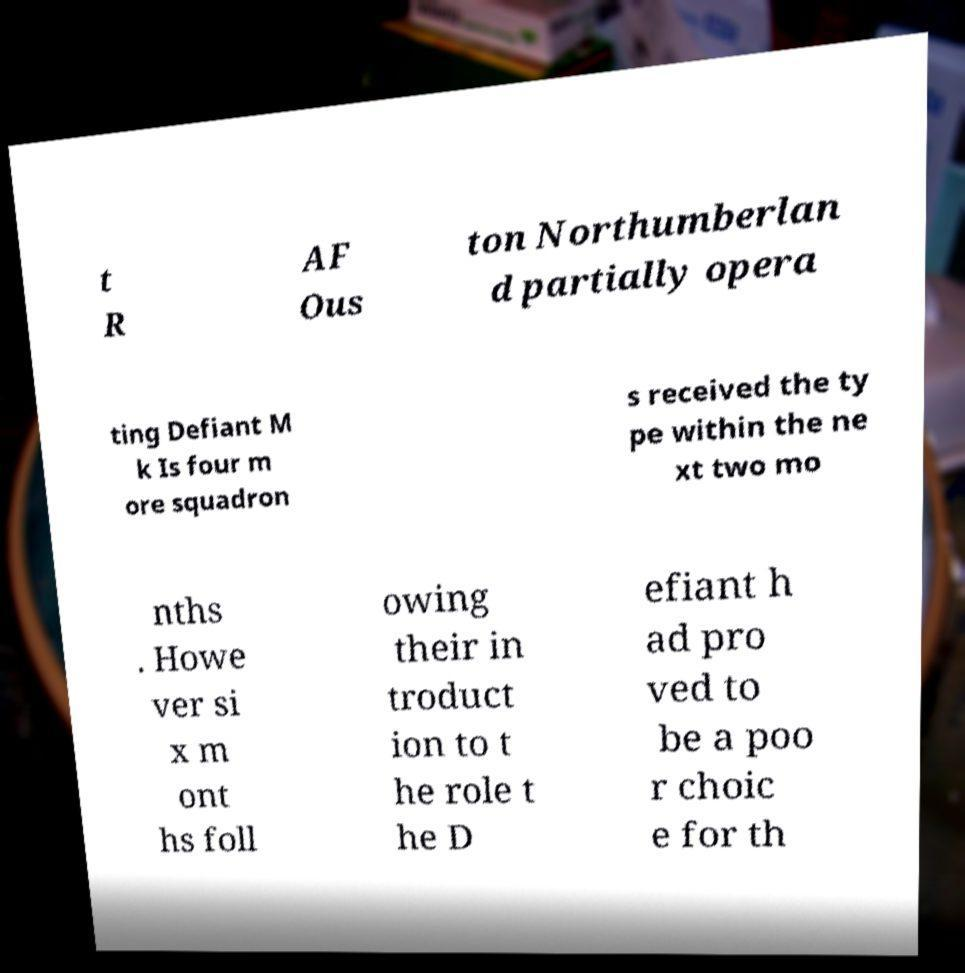Please identify and transcribe the text found in this image. t R AF Ous ton Northumberlan d partially opera ting Defiant M k Is four m ore squadron s received the ty pe within the ne xt two mo nths . Howe ver si x m ont hs foll owing their in troduct ion to t he role t he D efiant h ad pro ved to be a poo r choic e for th 